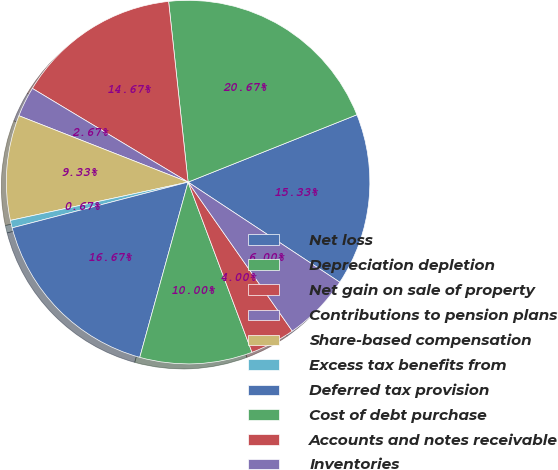Convert chart to OTSL. <chart><loc_0><loc_0><loc_500><loc_500><pie_chart><fcel>Net loss<fcel>Depreciation depletion<fcel>Net gain on sale of property<fcel>Contributions to pension plans<fcel>Share-based compensation<fcel>Excess tax benefits from<fcel>Deferred tax provision<fcel>Cost of debt purchase<fcel>Accounts and notes receivable<fcel>Inventories<nl><fcel>15.33%<fcel>20.67%<fcel>14.67%<fcel>2.67%<fcel>9.33%<fcel>0.67%<fcel>16.67%<fcel>10.0%<fcel>4.0%<fcel>6.0%<nl></chart> 